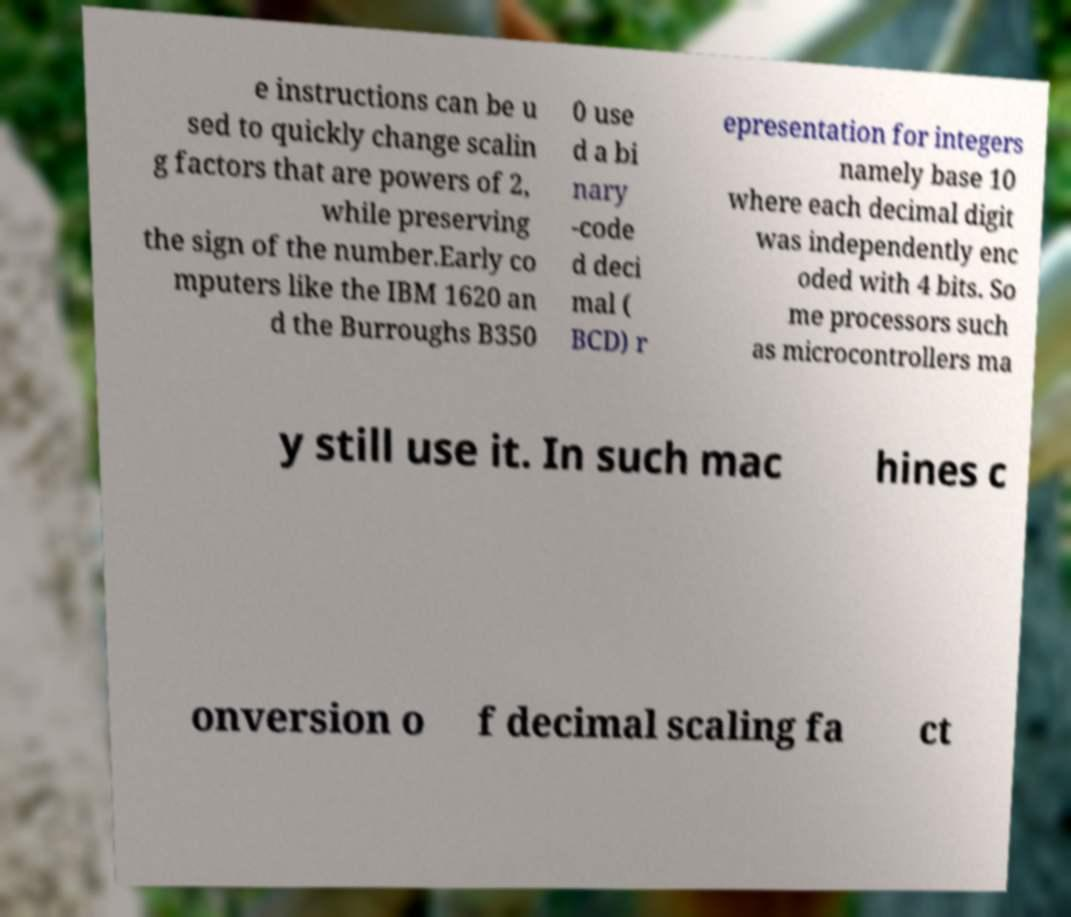Please read and relay the text visible in this image. What does it say? e instructions can be u sed to quickly change scalin g factors that are powers of 2, while preserving the sign of the number.Early co mputers like the IBM 1620 an d the Burroughs B350 0 use d a bi nary -code d deci mal ( BCD) r epresentation for integers namely base 10 where each decimal digit was independently enc oded with 4 bits. So me processors such as microcontrollers ma y still use it. In such mac hines c onversion o f decimal scaling fa ct 